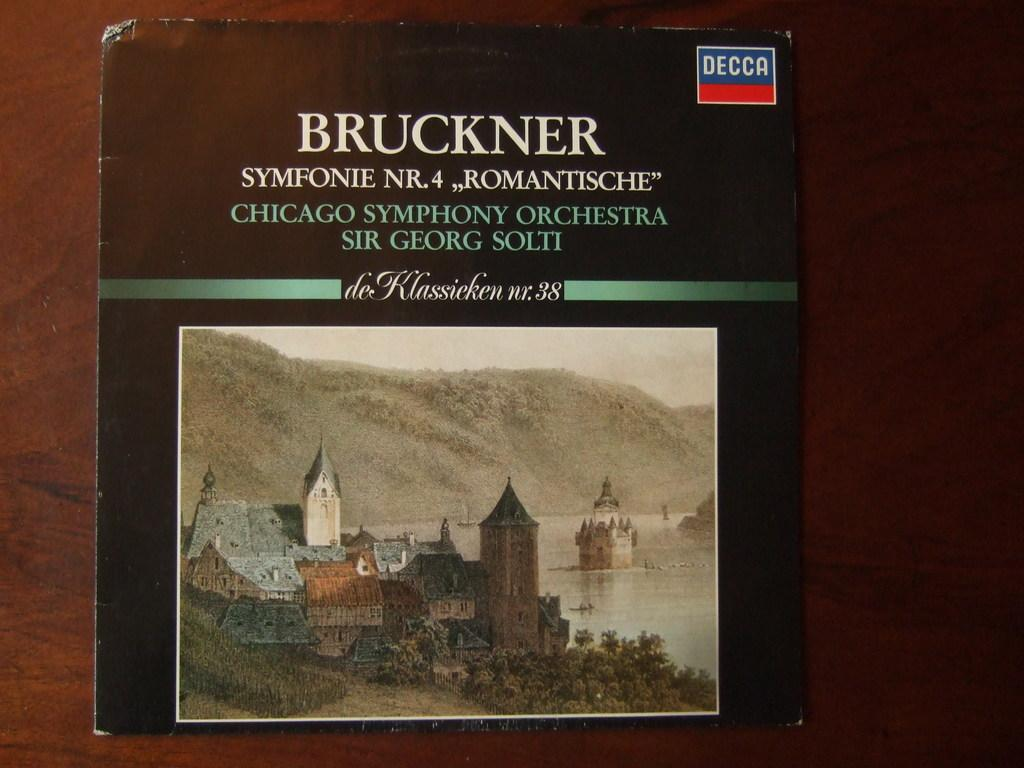<image>
Offer a succinct explanation of the picture presented. A cover to an older record that is titled, Bruckner. 